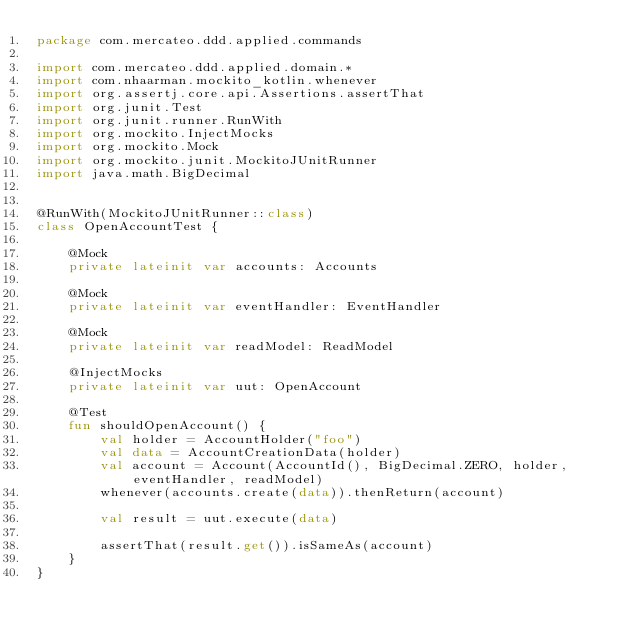Convert code to text. <code><loc_0><loc_0><loc_500><loc_500><_Kotlin_>package com.mercateo.ddd.applied.commands

import com.mercateo.ddd.applied.domain.*
import com.nhaarman.mockito_kotlin.whenever
import org.assertj.core.api.Assertions.assertThat
import org.junit.Test
import org.junit.runner.RunWith
import org.mockito.InjectMocks
import org.mockito.Mock
import org.mockito.junit.MockitoJUnitRunner
import java.math.BigDecimal


@RunWith(MockitoJUnitRunner::class)
class OpenAccountTest {

    @Mock
    private lateinit var accounts: Accounts

    @Mock
    private lateinit var eventHandler: EventHandler

    @Mock
    private lateinit var readModel: ReadModel

    @InjectMocks
    private lateinit var uut: OpenAccount

    @Test
    fun shouldOpenAccount() {
        val holder = AccountHolder("foo")
        val data = AccountCreationData(holder)
        val account = Account(AccountId(), BigDecimal.ZERO, holder, eventHandler, readModel)
        whenever(accounts.create(data)).thenReturn(account)

        val result = uut.execute(data)

        assertThat(result.get()).isSameAs(account)
    }
}</code> 